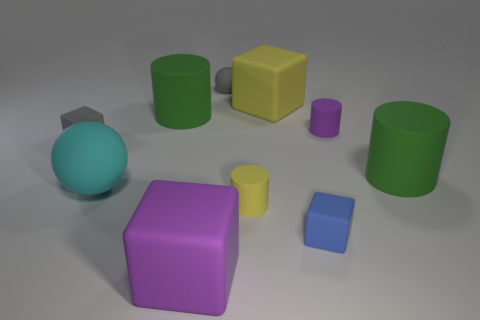Subtract all small gray matte cubes. How many cubes are left? 3 Subtract 2 balls. How many balls are left? 0 Subtract all cyan spheres. How many spheres are left? 1 Subtract 0 purple spheres. How many objects are left? 10 Subtract all balls. How many objects are left? 8 Subtract all cyan cubes. Subtract all yellow spheres. How many cubes are left? 4 Subtract all gray spheres. How many gray blocks are left? 1 Subtract all tiny blue rubber objects. Subtract all blue blocks. How many objects are left? 8 Add 5 large green cylinders. How many large green cylinders are left? 7 Add 5 large gray cubes. How many large gray cubes exist? 5 